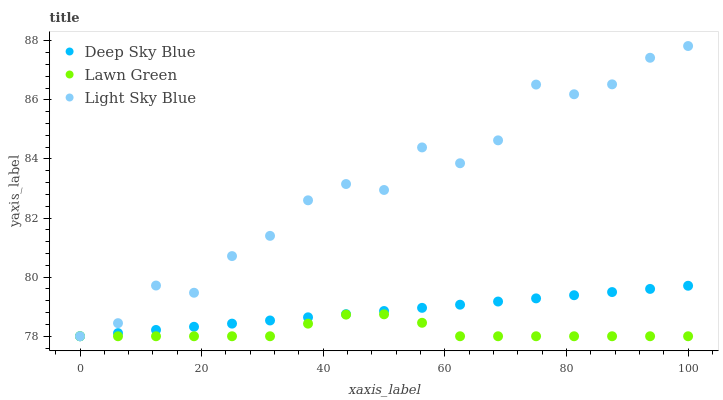Does Lawn Green have the minimum area under the curve?
Answer yes or no. Yes. Does Light Sky Blue have the maximum area under the curve?
Answer yes or no. Yes. Does Deep Sky Blue have the minimum area under the curve?
Answer yes or no. No. Does Deep Sky Blue have the maximum area under the curve?
Answer yes or no. No. Is Deep Sky Blue the smoothest?
Answer yes or no. Yes. Is Light Sky Blue the roughest?
Answer yes or no. Yes. Is Light Sky Blue the smoothest?
Answer yes or no. No. Is Deep Sky Blue the roughest?
Answer yes or no. No. Does Lawn Green have the lowest value?
Answer yes or no. Yes. Does Light Sky Blue have the highest value?
Answer yes or no. Yes. Does Deep Sky Blue have the highest value?
Answer yes or no. No. Does Deep Sky Blue intersect Lawn Green?
Answer yes or no. Yes. Is Deep Sky Blue less than Lawn Green?
Answer yes or no. No. Is Deep Sky Blue greater than Lawn Green?
Answer yes or no. No. 